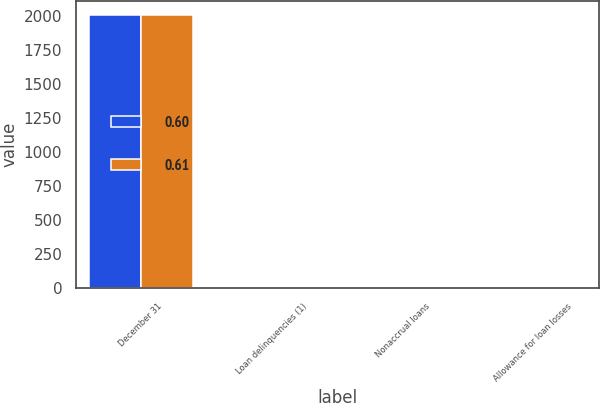Convert chart to OTSL. <chart><loc_0><loc_0><loc_500><loc_500><stacked_bar_chart><ecel><fcel>December 31<fcel>Loan delinquencies (1)<fcel>Nonaccrual loans<fcel>Allowance for loan losses<nl><fcel>0.6<fcel>2010<fcel>0.96<fcel>0.58<fcel>0.6<nl><fcel>0.61<fcel>2009<fcel>0.87<fcel>0.46<fcel>0.61<nl></chart> 